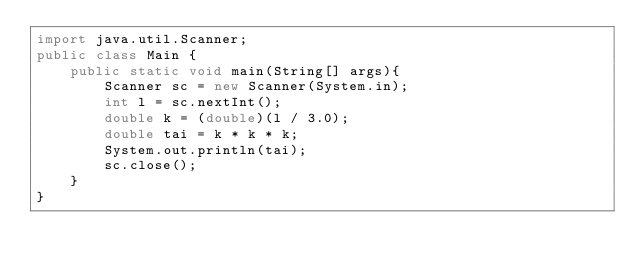<code> <loc_0><loc_0><loc_500><loc_500><_Java_>import java.util.Scanner;
public class Main {
    public static void main(String[] args){
        Scanner sc = new Scanner(System.in);
        int l = sc.nextInt();
        double k = (double)(l / 3.0);
        double tai = k * k * k;
        System.out.println(tai);
        sc.close();
    }
}</code> 